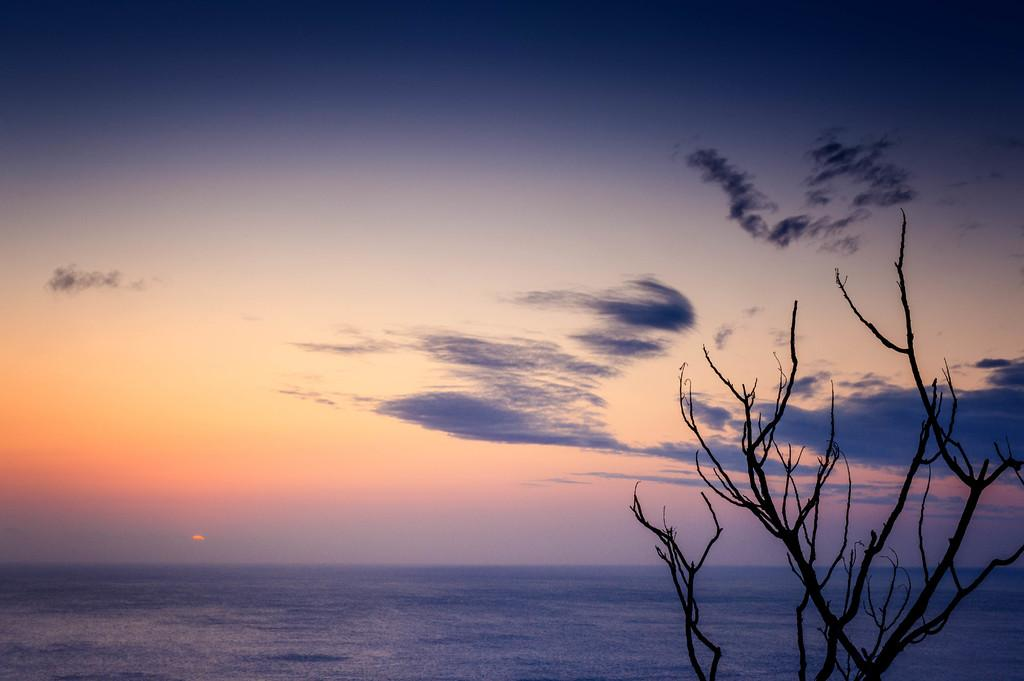What type of vegetation is on the right side of the image? There is a tree on the right side of the image. What is visible at the bottom of the image? There is water visible at the bottom of the image. What can be seen in the background of the image? The sky and clouds are visible in the background of the image. What type of power is being generated by the tree in the image? There is no indication of power generation in the image; it features a tree and water. What type of air is present in the image? The image does not specifically mention air, but it is reasonable to assume that the air is present as it is a natural element. However, the image does not focus on the air or provide any details about it. 